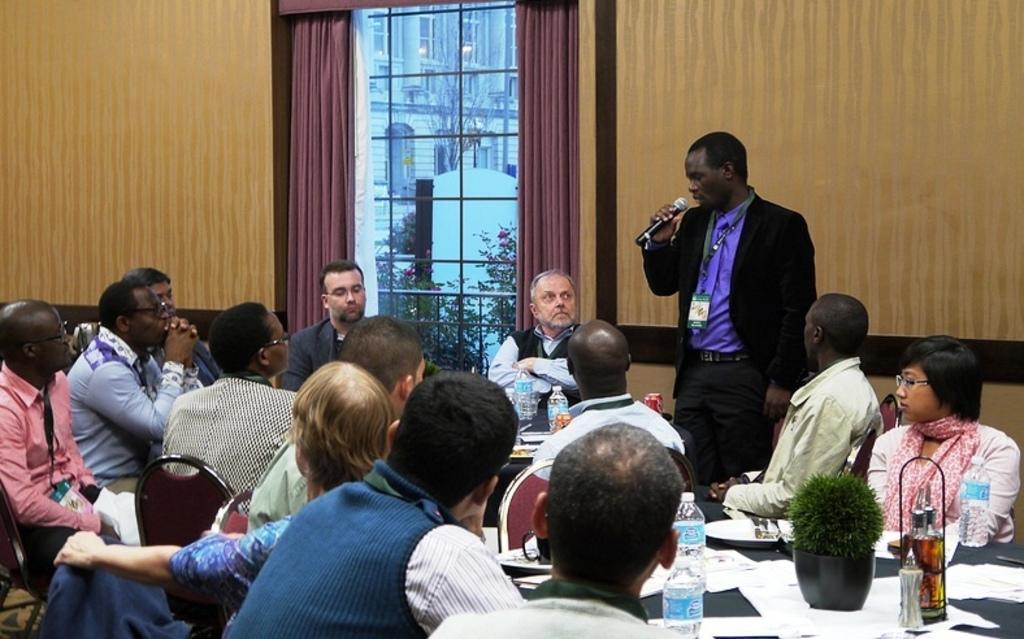Could you give a brief overview of what you see in this image? At the bottom of the image few people are sitting and there are some chairs and tables, on the tables there are some plates, bottles, papers, plants and tins. In the middle of the image a person is standing and holding a microphone. Behind him there is wall, on the wall there is a window and curtain. Through the window we can see some trees, plants and buildings. 